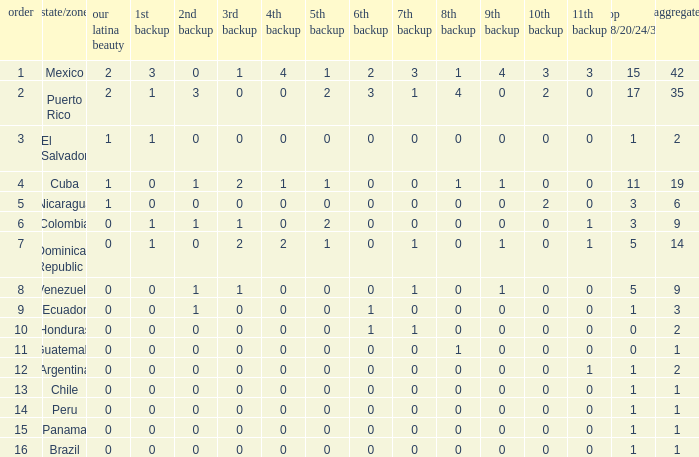What is the lowest 7th runner-up of the country with a top 18/20/24/30 greater than 5, a 1st runner-up greater than 0, and an 11th runner-up less than 0? None. 